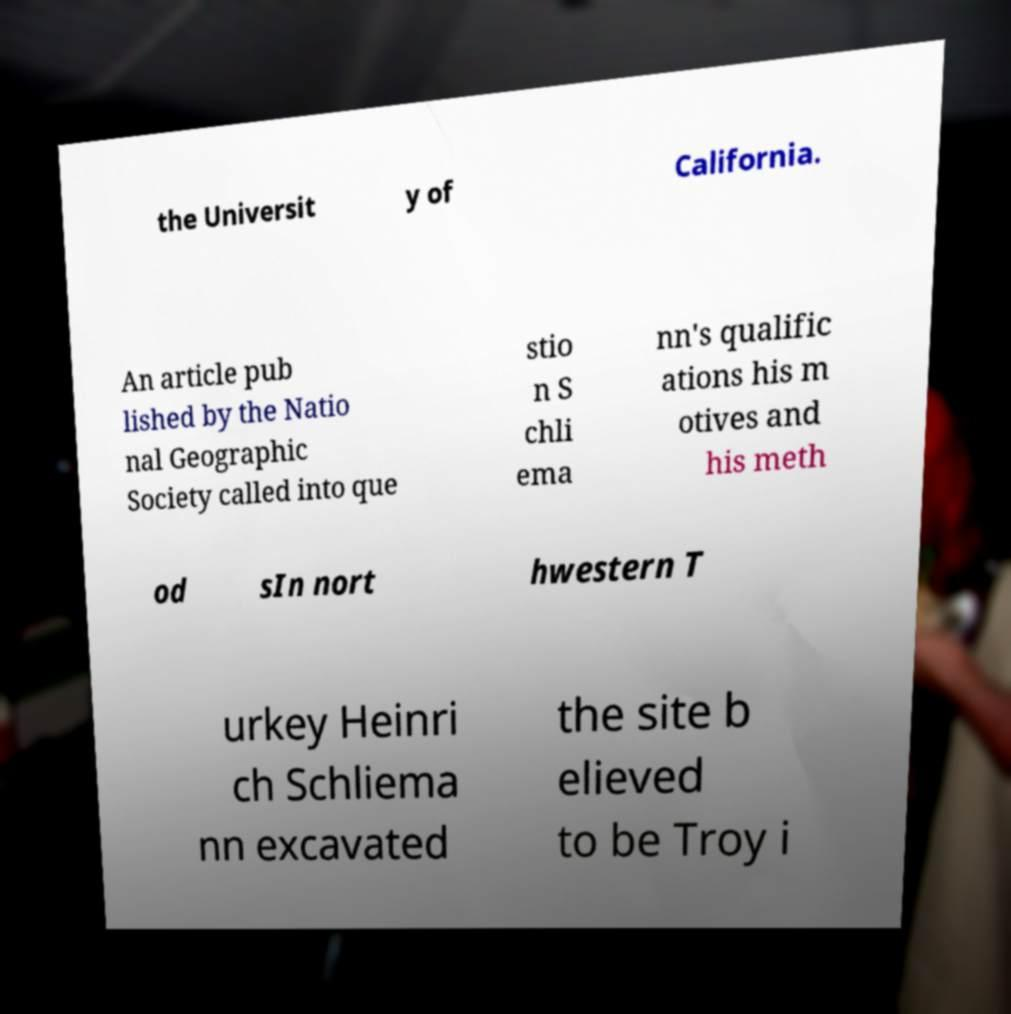Could you assist in decoding the text presented in this image and type it out clearly? the Universit y of California. An article pub lished by the Natio nal Geographic Society called into que stio n S chli ema nn's qualific ations his m otives and his meth od sIn nort hwestern T urkey Heinri ch Schliema nn excavated the site b elieved to be Troy i 